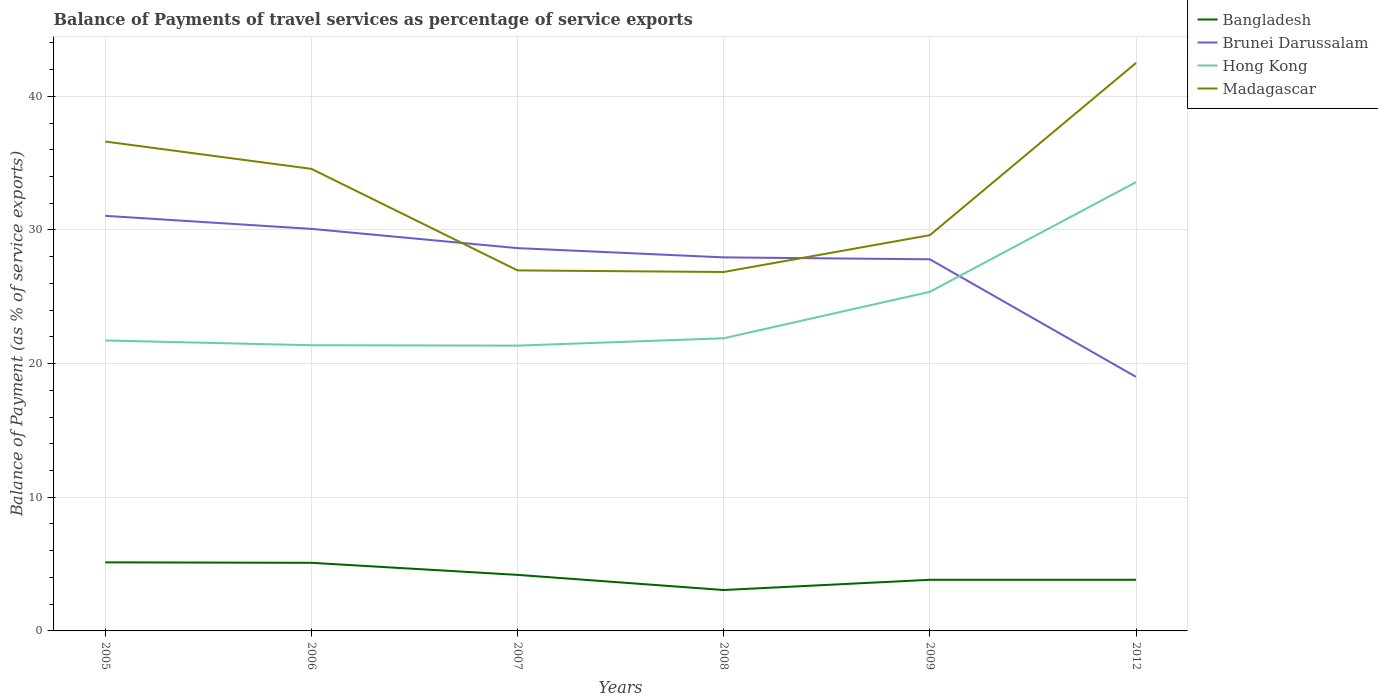Is the number of lines equal to the number of legend labels?
Provide a succinct answer. Yes. Across all years, what is the maximum balance of payments of travel services in Bangladesh?
Offer a very short reply. 3.06. What is the total balance of payments of travel services in Madagascar in the graph?
Your answer should be very brief. 7.01. What is the difference between the highest and the second highest balance of payments of travel services in Bangladesh?
Ensure brevity in your answer.  2.07. How many lines are there?
Your answer should be compact. 4. How many years are there in the graph?
Offer a terse response. 6. Are the values on the major ticks of Y-axis written in scientific E-notation?
Ensure brevity in your answer.  No. Does the graph contain any zero values?
Your answer should be very brief. No. Does the graph contain grids?
Make the answer very short. Yes. Where does the legend appear in the graph?
Make the answer very short. Top right. How are the legend labels stacked?
Your response must be concise. Vertical. What is the title of the graph?
Provide a succinct answer. Balance of Payments of travel services as percentage of service exports. Does "Moldova" appear as one of the legend labels in the graph?
Your answer should be compact. No. What is the label or title of the Y-axis?
Keep it short and to the point. Balance of Payment (as % of service exports). What is the Balance of Payment (as % of service exports) of Bangladesh in 2005?
Your answer should be compact. 5.13. What is the Balance of Payment (as % of service exports) in Brunei Darussalam in 2005?
Offer a terse response. 31.06. What is the Balance of Payment (as % of service exports) in Hong Kong in 2005?
Provide a short and direct response. 21.73. What is the Balance of Payment (as % of service exports) of Madagascar in 2005?
Provide a short and direct response. 36.61. What is the Balance of Payment (as % of service exports) of Bangladesh in 2006?
Your response must be concise. 5.1. What is the Balance of Payment (as % of service exports) in Brunei Darussalam in 2006?
Your response must be concise. 30.08. What is the Balance of Payment (as % of service exports) of Hong Kong in 2006?
Make the answer very short. 21.37. What is the Balance of Payment (as % of service exports) in Madagascar in 2006?
Provide a succinct answer. 34.57. What is the Balance of Payment (as % of service exports) of Bangladesh in 2007?
Give a very brief answer. 4.19. What is the Balance of Payment (as % of service exports) in Brunei Darussalam in 2007?
Give a very brief answer. 28.64. What is the Balance of Payment (as % of service exports) in Hong Kong in 2007?
Your response must be concise. 21.34. What is the Balance of Payment (as % of service exports) of Madagascar in 2007?
Provide a short and direct response. 26.97. What is the Balance of Payment (as % of service exports) of Bangladesh in 2008?
Your answer should be compact. 3.06. What is the Balance of Payment (as % of service exports) of Brunei Darussalam in 2008?
Give a very brief answer. 27.95. What is the Balance of Payment (as % of service exports) in Hong Kong in 2008?
Your answer should be compact. 21.9. What is the Balance of Payment (as % of service exports) in Madagascar in 2008?
Offer a terse response. 26.86. What is the Balance of Payment (as % of service exports) of Bangladesh in 2009?
Your response must be concise. 3.83. What is the Balance of Payment (as % of service exports) of Brunei Darussalam in 2009?
Offer a very short reply. 27.8. What is the Balance of Payment (as % of service exports) of Hong Kong in 2009?
Offer a terse response. 25.37. What is the Balance of Payment (as % of service exports) of Madagascar in 2009?
Provide a succinct answer. 29.61. What is the Balance of Payment (as % of service exports) in Bangladesh in 2012?
Your answer should be very brief. 3.83. What is the Balance of Payment (as % of service exports) of Brunei Darussalam in 2012?
Make the answer very short. 19.01. What is the Balance of Payment (as % of service exports) of Hong Kong in 2012?
Your answer should be compact. 33.58. What is the Balance of Payment (as % of service exports) in Madagascar in 2012?
Give a very brief answer. 42.5. Across all years, what is the maximum Balance of Payment (as % of service exports) in Bangladesh?
Offer a very short reply. 5.13. Across all years, what is the maximum Balance of Payment (as % of service exports) in Brunei Darussalam?
Your response must be concise. 31.06. Across all years, what is the maximum Balance of Payment (as % of service exports) of Hong Kong?
Keep it short and to the point. 33.58. Across all years, what is the maximum Balance of Payment (as % of service exports) of Madagascar?
Ensure brevity in your answer.  42.5. Across all years, what is the minimum Balance of Payment (as % of service exports) in Bangladesh?
Your answer should be very brief. 3.06. Across all years, what is the minimum Balance of Payment (as % of service exports) of Brunei Darussalam?
Give a very brief answer. 19.01. Across all years, what is the minimum Balance of Payment (as % of service exports) of Hong Kong?
Your answer should be compact. 21.34. Across all years, what is the minimum Balance of Payment (as % of service exports) of Madagascar?
Keep it short and to the point. 26.86. What is the total Balance of Payment (as % of service exports) of Bangladesh in the graph?
Provide a short and direct response. 25.13. What is the total Balance of Payment (as % of service exports) of Brunei Darussalam in the graph?
Your answer should be compact. 164.53. What is the total Balance of Payment (as % of service exports) in Hong Kong in the graph?
Give a very brief answer. 145.3. What is the total Balance of Payment (as % of service exports) of Madagascar in the graph?
Your response must be concise. 197.12. What is the difference between the Balance of Payment (as % of service exports) in Bangladesh in 2005 and that in 2006?
Ensure brevity in your answer.  0.04. What is the difference between the Balance of Payment (as % of service exports) in Brunei Darussalam in 2005 and that in 2006?
Your answer should be compact. 0.98. What is the difference between the Balance of Payment (as % of service exports) in Hong Kong in 2005 and that in 2006?
Keep it short and to the point. 0.36. What is the difference between the Balance of Payment (as % of service exports) in Madagascar in 2005 and that in 2006?
Ensure brevity in your answer.  2.04. What is the difference between the Balance of Payment (as % of service exports) in Bangladesh in 2005 and that in 2007?
Make the answer very short. 0.94. What is the difference between the Balance of Payment (as % of service exports) in Brunei Darussalam in 2005 and that in 2007?
Give a very brief answer. 2.42. What is the difference between the Balance of Payment (as % of service exports) of Hong Kong in 2005 and that in 2007?
Your answer should be very brief. 0.39. What is the difference between the Balance of Payment (as % of service exports) in Madagascar in 2005 and that in 2007?
Provide a short and direct response. 9.64. What is the difference between the Balance of Payment (as % of service exports) in Bangladesh in 2005 and that in 2008?
Provide a short and direct response. 2.07. What is the difference between the Balance of Payment (as % of service exports) in Brunei Darussalam in 2005 and that in 2008?
Offer a terse response. 3.11. What is the difference between the Balance of Payment (as % of service exports) of Hong Kong in 2005 and that in 2008?
Provide a short and direct response. -0.17. What is the difference between the Balance of Payment (as % of service exports) of Madagascar in 2005 and that in 2008?
Offer a terse response. 9.76. What is the difference between the Balance of Payment (as % of service exports) of Bangladesh in 2005 and that in 2009?
Keep it short and to the point. 1.31. What is the difference between the Balance of Payment (as % of service exports) of Brunei Darussalam in 2005 and that in 2009?
Make the answer very short. 3.25. What is the difference between the Balance of Payment (as % of service exports) of Hong Kong in 2005 and that in 2009?
Your answer should be compact. -3.64. What is the difference between the Balance of Payment (as % of service exports) of Madagascar in 2005 and that in 2009?
Provide a succinct answer. 7.01. What is the difference between the Balance of Payment (as % of service exports) in Bangladesh in 2005 and that in 2012?
Provide a succinct answer. 1.3. What is the difference between the Balance of Payment (as % of service exports) of Brunei Darussalam in 2005 and that in 2012?
Your response must be concise. 12.05. What is the difference between the Balance of Payment (as % of service exports) of Hong Kong in 2005 and that in 2012?
Offer a very short reply. -11.85. What is the difference between the Balance of Payment (as % of service exports) of Madagascar in 2005 and that in 2012?
Offer a very short reply. -5.88. What is the difference between the Balance of Payment (as % of service exports) in Bangladesh in 2006 and that in 2007?
Your answer should be compact. 0.9. What is the difference between the Balance of Payment (as % of service exports) in Brunei Darussalam in 2006 and that in 2007?
Give a very brief answer. 1.44. What is the difference between the Balance of Payment (as % of service exports) in Hong Kong in 2006 and that in 2007?
Give a very brief answer. 0.03. What is the difference between the Balance of Payment (as % of service exports) of Madagascar in 2006 and that in 2007?
Offer a very short reply. 7.6. What is the difference between the Balance of Payment (as % of service exports) in Bangladesh in 2006 and that in 2008?
Your response must be concise. 2.04. What is the difference between the Balance of Payment (as % of service exports) in Brunei Darussalam in 2006 and that in 2008?
Give a very brief answer. 2.13. What is the difference between the Balance of Payment (as % of service exports) of Hong Kong in 2006 and that in 2008?
Ensure brevity in your answer.  -0.52. What is the difference between the Balance of Payment (as % of service exports) in Madagascar in 2006 and that in 2008?
Provide a short and direct response. 7.72. What is the difference between the Balance of Payment (as % of service exports) in Bangladesh in 2006 and that in 2009?
Offer a terse response. 1.27. What is the difference between the Balance of Payment (as % of service exports) of Brunei Darussalam in 2006 and that in 2009?
Ensure brevity in your answer.  2.28. What is the difference between the Balance of Payment (as % of service exports) of Hong Kong in 2006 and that in 2009?
Ensure brevity in your answer.  -4. What is the difference between the Balance of Payment (as % of service exports) in Madagascar in 2006 and that in 2009?
Provide a short and direct response. 4.96. What is the difference between the Balance of Payment (as % of service exports) in Bangladesh in 2006 and that in 2012?
Offer a terse response. 1.27. What is the difference between the Balance of Payment (as % of service exports) in Brunei Darussalam in 2006 and that in 2012?
Your answer should be compact. 11.07. What is the difference between the Balance of Payment (as % of service exports) of Hong Kong in 2006 and that in 2012?
Offer a terse response. -12.2. What is the difference between the Balance of Payment (as % of service exports) of Madagascar in 2006 and that in 2012?
Your answer should be very brief. -7.92. What is the difference between the Balance of Payment (as % of service exports) of Bangladesh in 2007 and that in 2008?
Keep it short and to the point. 1.13. What is the difference between the Balance of Payment (as % of service exports) of Brunei Darussalam in 2007 and that in 2008?
Your response must be concise. 0.69. What is the difference between the Balance of Payment (as % of service exports) of Hong Kong in 2007 and that in 2008?
Ensure brevity in your answer.  -0.55. What is the difference between the Balance of Payment (as % of service exports) in Madagascar in 2007 and that in 2008?
Keep it short and to the point. 0.12. What is the difference between the Balance of Payment (as % of service exports) in Bangladesh in 2007 and that in 2009?
Your answer should be very brief. 0.37. What is the difference between the Balance of Payment (as % of service exports) in Brunei Darussalam in 2007 and that in 2009?
Your answer should be compact. 0.84. What is the difference between the Balance of Payment (as % of service exports) in Hong Kong in 2007 and that in 2009?
Your response must be concise. -4.03. What is the difference between the Balance of Payment (as % of service exports) in Madagascar in 2007 and that in 2009?
Provide a short and direct response. -2.64. What is the difference between the Balance of Payment (as % of service exports) in Bangladesh in 2007 and that in 2012?
Your response must be concise. 0.37. What is the difference between the Balance of Payment (as % of service exports) of Brunei Darussalam in 2007 and that in 2012?
Provide a short and direct response. 9.63. What is the difference between the Balance of Payment (as % of service exports) in Hong Kong in 2007 and that in 2012?
Offer a terse response. -12.23. What is the difference between the Balance of Payment (as % of service exports) in Madagascar in 2007 and that in 2012?
Your answer should be compact. -15.52. What is the difference between the Balance of Payment (as % of service exports) of Bangladesh in 2008 and that in 2009?
Provide a succinct answer. -0.77. What is the difference between the Balance of Payment (as % of service exports) of Brunei Darussalam in 2008 and that in 2009?
Provide a short and direct response. 0.14. What is the difference between the Balance of Payment (as % of service exports) of Hong Kong in 2008 and that in 2009?
Offer a very short reply. -3.48. What is the difference between the Balance of Payment (as % of service exports) in Madagascar in 2008 and that in 2009?
Keep it short and to the point. -2.75. What is the difference between the Balance of Payment (as % of service exports) in Bangladesh in 2008 and that in 2012?
Your response must be concise. -0.77. What is the difference between the Balance of Payment (as % of service exports) in Brunei Darussalam in 2008 and that in 2012?
Offer a very short reply. 8.94. What is the difference between the Balance of Payment (as % of service exports) in Hong Kong in 2008 and that in 2012?
Your answer should be compact. -11.68. What is the difference between the Balance of Payment (as % of service exports) in Madagascar in 2008 and that in 2012?
Your response must be concise. -15.64. What is the difference between the Balance of Payment (as % of service exports) in Bangladesh in 2009 and that in 2012?
Offer a terse response. -0. What is the difference between the Balance of Payment (as % of service exports) in Brunei Darussalam in 2009 and that in 2012?
Your answer should be compact. 8.8. What is the difference between the Balance of Payment (as % of service exports) in Hong Kong in 2009 and that in 2012?
Keep it short and to the point. -8.21. What is the difference between the Balance of Payment (as % of service exports) of Madagascar in 2009 and that in 2012?
Ensure brevity in your answer.  -12.89. What is the difference between the Balance of Payment (as % of service exports) of Bangladesh in 2005 and the Balance of Payment (as % of service exports) of Brunei Darussalam in 2006?
Provide a short and direct response. -24.95. What is the difference between the Balance of Payment (as % of service exports) in Bangladesh in 2005 and the Balance of Payment (as % of service exports) in Hong Kong in 2006?
Give a very brief answer. -16.24. What is the difference between the Balance of Payment (as % of service exports) of Bangladesh in 2005 and the Balance of Payment (as % of service exports) of Madagascar in 2006?
Keep it short and to the point. -29.44. What is the difference between the Balance of Payment (as % of service exports) in Brunei Darussalam in 2005 and the Balance of Payment (as % of service exports) in Hong Kong in 2006?
Offer a very short reply. 9.68. What is the difference between the Balance of Payment (as % of service exports) in Brunei Darussalam in 2005 and the Balance of Payment (as % of service exports) in Madagascar in 2006?
Provide a succinct answer. -3.51. What is the difference between the Balance of Payment (as % of service exports) in Hong Kong in 2005 and the Balance of Payment (as % of service exports) in Madagascar in 2006?
Your response must be concise. -12.84. What is the difference between the Balance of Payment (as % of service exports) in Bangladesh in 2005 and the Balance of Payment (as % of service exports) in Brunei Darussalam in 2007?
Offer a terse response. -23.51. What is the difference between the Balance of Payment (as % of service exports) of Bangladesh in 2005 and the Balance of Payment (as % of service exports) of Hong Kong in 2007?
Ensure brevity in your answer.  -16.21. What is the difference between the Balance of Payment (as % of service exports) in Bangladesh in 2005 and the Balance of Payment (as % of service exports) in Madagascar in 2007?
Offer a terse response. -21.84. What is the difference between the Balance of Payment (as % of service exports) in Brunei Darussalam in 2005 and the Balance of Payment (as % of service exports) in Hong Kong in 2007?
Your answer should be very brief. 9.71. What is the difference between the Balance of Payment (as % of service exports) in Brunei Darussalam in 2005 and the Balance of Payment (as % of service exports) in Madagascar in 2007?
Your answer should be very brief. 4.08. What is the difference between the Balance of Payment (as % of service exports) of Hong Kong in 2005 and the Balance of Payment (as % of service exports) of Madagascar in 2007?
Offer a terse response. -5.24. What is the difference between the Balance of Payment (as % of service exports) of Bangladesh in 2005 and the Balance of Payment (as % of service exports) of Brunei Darussalam in 2008?
Your answer should be very brief. -22.82. What is the difference between the Balance of Payment (as % of service exports) of Bangladesh in 2005 and the Balance of Payment (as % of service exports) of Hong Kong in 2008?
Your answer should be compact. -16.77. What is the difference between the Balance of Payment (as % of service exports) of Bangladesh in 2005 and the Balance of Payment (as % of service exports) of Madagascar in 2008?
Provide a succinct answer. -21.72. What is the difference between the Balance of Payment (as % of service exports) of Brunei Darussalam in 2005 and the Balance of Payment (as % of service exports) of Hong Kong in 2008?
Provide a succinct answer. 9.16. What is the difference between the Balance of Payment (as % of service exports) in Brunei Darussalam in 2005 and the Balance of Payment (as % of service exports) in Madagascar in 2008?
Provide a short and direct response. 4.2. What is the difference between the Balance of Payment (as % of service exports) of Hong Kong in 2005 and the Balance of Payment (as % of service exports) of Madagascar in 2008?
Provide a succinct answer. -5.13. What is the difference between the Balance of Payment (as % of service exports) in Bangladesh in 2005 and the Balance of Payment (as % of service exports) in Brunei Darussalam in 2009?
Keep it short and to the point. -22.67. What is the difference between the Balance of Payment (as % of service exports) of Bangladesh in 2005 and the Balance of Payment (as % of service exports) of Hong Kong in 2009?
Provide a succinct answer. -20.24. What is the difference between the Balance of Payment (as % of service exports) in Bangladesh in 2005 and the Balance of Payment (as % of service exports) in Madagascar in 2009?
Provide a succinct answer. -24.48. What is the difference between the Balance of Payment (as % of service exports) in Brunei Darussalam in 2005 and the Balance of Payment (as % of service exports) in Hong Kong in 2009?
Make the answer very short. 5.68. What is the difference between the Balance of Payment (as % of service exports) in Brunei Darussalam in 2005 and the Balance of Payment (as % of service exports) in Madagascar in 2009?
Your response must be concise. 1.45. What is the difference between the Balance of Payment (as % of service exports) of Hong Kong in 2005 and the Balance of Payment (as % of service exports) of Madagascar in 2009?
Provide a short and direct response. -7.88. What is the difference between the Balance of Payment (as % of service exports) of Bangladesh in 2005 and the Balance of Payment (as % of service exports) of Brunei Darussalam in 2012?
Ensure brevity in your answer.  -13.88. What is the difference between the Balance of Payment (as % of service exports) of Bangladesh in 2005 and the Balance of Payment (as % of service exports) of Hong Kong in 2012?
Keep it short and to the point. -28.45. What is the difference between the Balance of Payment (as % of service exports) of Bangladesh in 2005 and the Balance of Payment (as % of service exports) of Madagascar in 2012?
Provide a short and direct response. -37.36. What is the difference between the Balance of Payment (as % of service exports) in Brunei Darussalam in 2005 and the Balance of Payment (as % of service exports) in Hong Kong in 2012?
Give a very brief answer. -2.52. What is the difference between the Balance of Payment (as % of service exports) of Brunei Darussalam in 2005 and the Balance of Payment (as % of service exports) of Madagascar in 2012?
Provide a short and direct response. -11.44. What is the difference between the Balance of Payment (as % of service exports) of Hong Kong in 2005 and the Balance of Payment (as % of service exports) of Madagascar in 2012?
Ensure brevity in your answer.  -20.77. What is the difference between the Balance of Payment (as % of service exports) of Bangladesh in 2006 and the Balance of Payment (as % of service exports) of Brunei Darussalam in 2007?
Offer a very short reply. -23.54. What is the difference between the Balance of Payment (as % of service exports) of Bangladesh in 2006 and the Balance of Payment (as % of service exports) of Hong Kong in 2007?
Provide a short and direct response. -16.25. What is the difference between the Balance of Payment (as % of service exports) of Bangladesh in 2006 and the Balance of Payment (as % of service exports) of Madagascar in 2007?
Your response must be concise. -21.88. What is the difference between the Balance of Payment (as % of service exports) in Brunei Darussalam in 2006 and the Balance of Payment (as % of service exports) in Hong Kong in 2007?
Ensure brevity in your answer.  8.74. What is the difference between the Balance of Payment (as % of service exports) in Brunei Darussalam in 2006 and the Balance of Payment (as % of service exports) in Madagascar in 2007?
Provide a short and direct response. 3.11. What is the difference between the Balance of Payment (as % of service exports) in Hong Kong in 2006 and the Balance of Payment (as % of service exports) in Madagascar in 2007?
Provide a short and direct response. -5.6. What is the difference between the Balance of Payment (as % of service exports) of Bangladesh in 2006 and the Balance of Payment (as % of service exports) of Brunei Darussalam in 2008?
Provide a succinct answer. -22.85. What is the difference between the Balance of Payment (as % of service exports) in Bangladesh in 2006 and the Balance of Payment (as % of service exports) in Hong Kong in 2008?
Your answer should be very brief. -16.8. What is the difference between the Balance of Payment (as % of service exports) of Bangladesh in 2006 and the Balance of Payment (as % of service exports) of Madagascar in 2008?
Provide a short and direct response. -21.76. What is the difference between the Balance of Payment (as % of service exports) in Brunei Darussalam in 2006 and the Balance of Payment (as % of service exports) in Hong Kong in 2008?
Provide a succinct answer. 8.18. What is the difference between the Balance of Payment (as % of service exports) in Brunei Darussalam in 2006 and the Balance of Payment (as % of service exports) in Madagascar in 2008?
Provide a succinct answer. 3.23. What is the difference between the Balance of Payment (as % of service exports) of Hong Kong in 2006 and the Balance of Payment (as % of service exports) of Madagascar in 2008?
Your answer should be compact. -5.48. What is the difference between the Balance of Payment (as % of service exports) of Bangladesh in 2006 and the Balance of Payment (as % of service exports) of Brunei Darussalam in 2009?
Provide a short and direct response. -22.71. What is the difference between the Balance of Payment (as % of service exports) in Bangladesh in 2006 and the Balance of Payment (as % of service exports) in Hong Kong in 2009?
Keep it short and to the point. -20.28. What is the difference between the Balance of Payment (as % of service exports) of Bangladesh in 2006 and the Balance of Payment (as % of service exports) of Madagascar in 2009?
Your answer should be very brief. -24.51. What is the difference between the Balance of Payment (as % of service exports) of Brunei Darussalam in 2006 and the Balance of Payment (as % of service exports) of Hong Kong in 2009?
Your response must be concise. 4.71. What is the difference between the Balance of Payment (as % of service exports) in Brunei Darussalam in 2006 and the Balance of Payment (as % of service exports) in Madagascar in 2009?
Ensure brevity in your answer.  0.47. What is the difference between the Balance of Payment (as % of service exports) of Hong Kong in 2006 and the Balance of Payment (as % of service exports) of Madagascar in 2009?
Provide a short and direct response. -8.23. What is the difference between the Balance of Payment (as % of service exports) in Bangladesh in 2006 and the Balance of Payment (as % of service exports) in Brunei Darussalam in 2012?
Offer a terse response. -13.91. What is the difference between the Balance of Payment (as % of service exports) of Bangladesh in 2006 and the Balance of Payment (as % of service exports) of Hong Kong in 2012?
Keep it short and to the point. -28.48. What is the difference between the Balance of Payment (as % of service exports) in Bangladesh in 2006 and the Balance of Payment (as % of service exports) in Madagascar in 2012?
Give a very brief answer. -37.4. What is the difference between the Balance of Payment (as % of service exports) of Brunei Darussalam in 2006 and the Balance of Payment (as % of service exports) of Hong Kong in 2012?
Keep it short and to the point. -3.5. What is the difference between the Balance of Payment (as % of service exports) of Brunei Darussalam in 2006 and the Balance of Payment (as % of service exports) of Madagascar in 2012?
Make the answer very short. -12.42. What is the difference between the Balance of Payment (as % of service exports) of Hong Kong in 2006 and the Balance of Payment (as % of service exports) of Madagascar in 2012?
Offer a terse response. -21.12. What is the difference between the Balance of Payment (as % of service exports) of Bangladesh in 2007 and the Balance of Payment (as % of service exports) of Brunei Darussalam in 2008?
Your answer should be compact. -23.75. What is the difference between the Balance of Payment (as % of service exports) of Bangladesh in 2007 and the Balance of Payment (as % of service exports) of Hong Kong in 2008?
Offer a very short reply. -17.7. What is the difference between the Balance of Payment (as % of service exports) in Bangladesh in 2007 and the Balance of Payment (as % of service exports) in Madagascar in 2008?
Make the answer very short. -22.66. What is the difference between the Balance of Payment (as % of service exports) in Brunei Darussalam in 2007 and the Balance of Payment (as % of service exports) in Hong Kong in 2008?
Your answer should be compact. 6.74. What is the difference between the Balance of Payment (as % of service exports) of Brunei Darussalam in 2007 and the Balance of Payment (as % of service exports) of Madagascar in 2008?
Give a very brief answer. 1.78. What is the difference between the Balance of Payment (as % of service exports) in Hong Kong in 2007 and the Balance of Payment (as % of service exports) in Madagascar in 2008?
Keep it short and to the point. -5.51. What is the difference between the Balance of Payment (as % of service exports) in Bangladesh in 2007 and the Balance of Payment (as % of service exports) in Brunei Darussalam in 2009?
Offer a terse response. -23.61. What is the difference between the Balance of Payment (as % of service exports) in Bangladesh in 2007 and the Balance of Payment (as % of service exports) in Hong Kong in 2009?
Your response must be concise. -21.18. What is the difference between the Balance of Payment (as % of service exports) of Bangladesh in 2007 and the Balance of Payment (as % of service exports) of Madagascar in 2009?
Offer a terse response. -25.42. What is the difference between the Balance of Payment (as % of service exports) in Brunei Darussalam in 2007 and the Balance of Payment (as % of service exports) in Hong Kong in 2009?
Your response must be concise. 3.27. What is the difference between the Balance of Payment (as % of service exports) of Brunei Darussalam in 2007 and the Balance of Payment (as % of service exports) of Madagascar in 2009?
Provide a short and direct response. -0.97. What is the difference between the Balance of Payment (as % of service exports) of Hong Kong in 2007 and the Balance of Payment (as % of service exports) of Madagascar in 2009?
Offer a very short reply. -8.26. What is the difference between the Balance of Payment (as % of service exports) in Bangladesh in 2007 and the Balance of Payment (as % of service exports) in Brunei Darussalam in 2012?
Provide a short and direct response. -14.81. What is the difference between the Balance of Payment (as % of service exports) of Bangladesh in 2007 and the Balance of Payment (as % of service exports) of Hong Kong in 2012?
Provide a succinct answer. -29.38. What is the difference between the Balance of Payment (as % of service exports) in Bangladesh in 2007 and the Balance of Payment (as % of service exports) in Madagascar in 2012?
Provide a short and direct response. -38.3. What is the difference between the Balance of Payment (as % of service exports) of Brunei Darussalam in 2007 and the Balance of Payment (as % of service exports) of Hong Kong in 2012?
Make the answer very short. -4.94. What is the difference between the Balance of Payment (as % of service exports) in Brunei Darussalam in 2007 and the Balance of Payment (as % of service exports) in Madagascar in 2012?
Keep it short and to the point. -13.86. What is the difference between the Balance of Payment (as % of service exports) in Hong Kong in 2007 and the Balance of Payment (as % of service exports) in Madagascar in 2012?
Offer a terse response. -21.15. What is the difference between the Balance of Payment (as % of service exports) in Bangladesh in 2008 and the Balance of Payment (as % of service exports) in Brunei Darussalam in 2009?
Your answer should be compact. -24.74. What is the difference between the Balance of Payment (as % of service exports) in Bangladesh in 2008 and the Balance of Payment (as % of service exports) in Hong Kong in 2009?
Provide a succinct answer. -22.31. What is the difference between the Balance of Payment (as % of service exports) of Bangladesh in 2008 and the Balance of Payment (as % of service exports) of Madagascar in 2009?
Your response must be concise. -26.55. What is the difference between the Balance of Payment (as % of service exports) in Brunei Darussalam in 2008 and the Balance of Payment (as % of service exports) in Hong Kong in 2009?
Provide a short and direct response. 2.58. What is the difference between the Balance of Payment (as % of service exports) in Brunei Darussalam in 2008 and the Balance of Payment (as % of service exports) in Madagascar in 2009?
Your answer should be compact. -1.66. What is the difference between the Balance of Payment (as % of service exports) of Hong Kong in 2008 and the Balance of Payment (as % of service exports) of Madagascar in 2009?
Offer a very short reply. -7.71. What is the difference between the Balance of Payment (as % of service exports) of Bangladesh in 2008 and the Balance of Payment (as % of service exports) of Brunei Darussalam in 2012?
Offer a very short reply. -15.95. What is the difference between the Balance of Payment (as % of service exports) in Bangladesh in 2008 and the Balance of Payment (as % of service exports) in Hong Kong in 2012?
Make the answer very short. -30.52. What is the difference between the Balance of Payment (as % of service exports) of Bangladesh in 2008 and the Balance of Payment (as % of service exports) of Madagascar in 2012?
Give a very brief answer. -39.44. What is the difference between the Balance of Payment (as % of service exports) in Brunei Darussalam in 2008 and the Balance of Payment (as % of service exports) in Hong Kong in 2012?
Give a very brief answer. -5.63. What is the difference between the Balance of Payment (as % of service exports) in Brunei Darussalam in 2008 and the Balance of Payment (as % of service exports) in Madagascar in 2012?
Make the answer very short. -14.55. What is the difference between the Balance of Payment (as % of service exports) of Hong Kong in 2008 and the Balance of Payment (as % of service exports) of Madagascar in 2012?
Your answer should be very brief. -20.6. What is the difference between the Balance of Payment (as % of service exports) in Bangladesh in 2009 and the Balance of Payment (as % of service exports) in Brunei Darussalam in 2012?
Your answer should be very brief. -15.18. What is the difference between the Balance of Payment (as % of service exports) of Bangladesh in 2009 and the Balance of Payment (as % of service exports) of Hong Kong in 2012?
Your answer should be very brief. -29.75. What is the difference between the Balance of Payment (as % of service exports) in Bangladesh in 2009 and the Balance of Payment (as % of service exports) in Madagascar in 2012?
Offer a very short reply. -38.67. What is the difference between the Balance of Payment (as % of service exports) in Brunei Darussalam in 2009 and the Balance of Payment (as % of service exports) in Hong Kong in 2012?
Keep it short and to the point. -5.77. What is the difference between the Balance of Payment (as % of service exports) of Brunei Darussalam in 2009 and the Balance of Payment (as % of service exports) of Madagascar in 2012?
Ensure brevity in your answer.  -14.69. What is the difference between the Balance of Payment (as % of service exports) of Hong Kong in 2009 and the Balance of Payment (as % of service exports) of Madagascar in 2012?
Keep it short and to the point. -17.12. What is the average Balance of Payment (as % of service exports) of Bangladesh per year?
Offer a very short reply. 4.19. What is the average Balance of Payment (as % of service exports) in Brunei Darussalam per year?
Your response must be concise. 27.42. What is the average Balance of Payment (as % of service exports) in Hong Kong per year?
Offer a terse response. 24.22. What is the average Balance of Payment (as % of service exports) of Madagascar per year?
Ensure brevity in your answer.  32.85. In the year 2005, what is the difference between the Balance of Payment (as % of service exports) of Bangladesh and Balance of Payment (as % of service exports) of Brunei Darussalam?
Keep it short and to the point. -25.93. In the year 2005, what is the difference between the Balance of Payment (as % of service exports) of Bangladesh and Balance of Payment (as % of service exports) of Hong Kong?
Ensure brevity in your answer.  -16.6. In the year 2005, what is the difference between the Balance of Payment (as % of service exports) of Bangladesh and Balance of Payment (as % of service exports) of Madagascar?
Give a very brief answer. -31.48. In the year 2005, what is the difference between the Balance of Payment (as % of service exports) in Brunei Darussalam and Balance of Payment (as % of service exports) in Hong Kong?
Provide a succinct answer. 9.33. In the year 2005, what is the difference between the Balance of Payment (as % of service exports) in Brunei Darussalam and Balance of Payment (as % of service exports) in Madagascar?
Your answer should be compact. -5.56. In the year 2005, what is the difference between the Balance of Payment (as % of service exports) in Hong Kong and Balance of Payment (as % of service exports) in Madagascar?
Your response must be concise. -14.88. In the year 2006, what is the difference between the Balance of Payment (as % of service exports) of Bangladesh and Balance of Payment (as % of service exports) of Brunei Darussalam?
Keep it short and to the point. -24.98. In the year 2006, what is the difference between the Balance of Payment (as % of service exports) in Bangladesh and Balance of Payment (as % of service exports) in Hong Kong?
Offer a terse response. -16.28. In the year 2006, what is the difference between the Balance of Payment (as % of service exports) of Bangladesh and Balance of Payment (as % of service exports) of Madagascar?
Ensure brevity in your answer.  -29.48. In the year 2006, what is the difference between the Balance of Payment (as % of service exports) in Brunei Darussalam and Balance of Payment (as % of service exports) in Hong Kong?
Your answer should be compact. 8.71. In the year 2006, what is the difference between the Balance of Payment (as % of service exports) in Brunei Darussalam and Balance of Payment (as % of service exports) in Madagascar?
Your answer should be compact. -4.49. In the year 2006, what is the difference between the Balance of Payment (as % of service exports) in Hong Kong and Balance of Payment (as % of service exports) in Madagascar?
Give a very brief answer. -13.2. In the year 2007, what is the difference between the Balance of Payment (as % of service exports) in Bangladesh and Balance of Payment (as % of service exports) in Brunei Darussalam?
Provide a succinct answer. -24.45. In the year 2007, what is the difference between the Balance of Payment (as % of service exports) of Bangladesh and Balance of Payment (as % of service exports) of Hong Kong?
Provide a short and direct response. -17.15. In the year 2007, what is the difference between the Balance of Payment (as % of service exports) in Bangladesh and Balance of Payment (as % of service exports) in Madagascar?
Ensure brevity in your answer.  -22.78. In the year 2007, what is the difference between the Balance of Payment (as % of service exports) in Brunei Darussalam and Balance of Payment (as % of service exports) in Hong Kong?
Keep it short and to the point. 7.3. In the year 2007, what is the difference between the Balance of Payment (as % of service exports) of Brunei Darussalam and Balance of Payment (as % of service exports) of Madagascar?
Provide a succinct answer. 1.67. In the year 2007, what is the difference between the Balance of Payment (as % of service exports) in Hong Kong and Balance of Payment (as % of service exports) in Madagascar?
Your response must be concise. -5.63. In the year 2008, what is the difference between the Balance of Payment (as % of service exports) in Bangladesh and Balance of Payment (as % of service exports) in Brunei Darussalam?
Your answer should be compact. -24.89. In the year 2008, what is the difference between the Balance of Payment (as % of service exports) in Bangladesh and Balance of Payment (as % of service exports) in Hong Kong?
Make the answer very short. -18.84. In the year 2008, what is the difference between the Balance of Payment (as % of service exports) of Bangladesh and Balance of Payment (as % of service exports) of Madagascar?
Give a very brief answer. -23.79. In the year 2008, what is the difference between the Balance of Payment (as % of service exports) of Brunei Darussalam and Balance of Payment (as % of service exports) of Hong Kong?
Offer a very short reply. 6.05. In the year 2008, what is the difference between the Balance of Payment (as % of service exports) in Brunei Darussalam and Balance of Payment (as % of service exports) in Madagascar?
Your response must be concise. 1.09. In the year 2008, what is the difference between the Balance of Payment (as % of service exports) of Hong Kong and Balance of Payment (as % of service exports) of Madagascar?
Provide a short and direct response. -4.96. In the year 2009, what is the difference between the Balance of Payment (as % of service exports) of Bangladesh and Balance of Payment (as % of service exports) of Brunei Darussalam?
Your answer should be compact. -23.98. In the year 2009, what is the difference between the Balance of Payment (as % of service exports) of Bangladesh and Balance of Payment (as % of service exports) of Hong Kong?
Give a very brief answer. -21.55. In the year 2009, what is the difference between the Balance of Payment (as % of service exports) of Bangladesh and Balance of Payment (as % of service exports) of Madagascar?
Ensure brevity in your answer.  -25.78. In the year 2009, what is the difference between the Balance of Payment (as % of service exports) of Brunei Darussalam and Balance of Payment (as % of service exports) of Hong Kong?
Your answer should be very brief. 2.43. In the year 2009, what is the difference between the Balance of Payment (as % of service exports) of Brunei Darussalam and Balance of Payment (as % of service exports) of Madagascar?
Your answer should be compact. -1.81. In the year 2009, what is the difference between the Balance of Payment (as % of service exports) of Hong Kong and Balance of Payment (as % of service exports) of Madagascar?
Offer a terse response. -4.24. In the year 2012, what is the difference between the Balance of Payment (as % of service exports) in Bangladesh and Balance of Payment (as % of service exports) in Brunei Darussalam?
Provide a short and direct response. -15.18. In the year 2012, what is the difference between the Balance of Payment (as % of service exports) in Bangladesh and Balance of Payment (as % of service exports) in Hong Kong?
Provide a short and direct response. -29.75. In the year 2012, what is the difference between the Balance of Payment (as % of service exports) in Bangladesh and Balance of Payment (as % of service exports) in Madagascar?
Your response must be concise. -38.67. In the year 2012, what is the difference between the Balance of Payment (as % of service exports) in Brunei Darussalam and Balance of Payment (as % of service exports) in Hong Kong?
Give a very brief answer. -14.57. In the year 2012, what is the difference between the Balance of Payment (as % of service exports) in Brunei Darussalam and Balance of Payment (as % of service exports) in Madagascar?
Your answer should be compact. -23.49. In the year 2012, what is the difference between the Balance of Payment (as % of service exports) in Hong Kong and Balance of Payment (as % of service exports) in Madagascar?
Provide a succinct answer. -8.92. What is the ratio of the Balance of Payment (as % of service exports) of Bangladesh in 2005 to that in 2006?
Ensure brevity in your answer.  1.01. What is the ratio of the Balance of Payment (as % of service exports) of Brunei Darussalam in 2005 to that in 2006?
Your answer should be compact. 1.03. What is the ratio of the Balance of Payment (as % of service exports) of Hong Kong in 2005 to that in 2006?
Your response must be concise. 1.02. What is the ratio of the Balance of Payment (as % of service exports) in Madagascar in 2005 to that in 2006?
Make the answer very short. 1.06. What is the ratio of the Balance of Payment (as % of service exports) in Bangladesh in 2005 to that in 2007?
Offer a very short reply. 1.22. What is the ratio of the Balance of Payment (as % of service exports) in Brunei Darussalam in 2005 to that in 2007?
Your response must be concise. 1.08. What is the ratio of the Balance of Payment (as % of service exports) of Hong Kong in 2005 to that in 2007?
Your answer should be compact. 1.02. What is the ratio of the Balance of Payment (as % of service exports) of Madagascar in 2005 to that in 2007?
Keep it short and to the point. 1.36. What is the ratio of the Balance of Payment (as % of service exports) of Bangladesh in 2005 to that in 2008?
Provide a succinct answer. 1.68. What is the ratio of the Balance of Payment (as % of service exports) in Brunei Darussalam in 2005 to that in 2008?
Provide a succinct answer. 1.11. What is the ratio of the Balance of Payment (as % of service exports) of Hong Kong in 2005 to that in 2008?
Give a very brief answer. 0.99. What is the ratio of the Balance of Payment (as % of service exports) of Madagascar in 2005 to that in 2008?
Your answer should be very brief. 1.36. What is the ratio of the Balance of Payment (as % of service exports) in Bangladesh in 2005 to that in 2009?
Keep it short and to the point. 1.34. What is the ratio of the Balance of Payment (as % of service exports) in Brunei Darussalam in 2005 to that in 2009?
Your answer should be very brief. 1.12. What is the ratio of the Balance of Payment (as % of service exports) in Hong Kong in 2005 to that in 2009?
Your answer should be very brief. 0.86. What is the ratio of the Balance of Payment (as % of service exports) in Madagascar in 2005 to that in 2009?
Keep it short and to the point. 1.24. What is the ratio of the Balance of Payment (as % of service exports) of Bangladesh in 2005 to that in 2012?
Offer a very short reply. 1.34. What is the ratio of the Balance of Payment (as % of service exports) in Brunei Darussalam in 2005 to that in 2012?
Provide a short and direct response. 1.63. What is the ratio of the Balance of Payment (as % of service exports) in Hong Kong in 2005 to that in 2012?
Offer a terse response. 0.65. What is the ratio of the Balance of Payment (as % of service exports) of Madagascar in 2005 to that in 2012?
Ensure brevity in your answer.  0.86. What is the ratio of the Balance of Payment (as % of service exports) of Bangladesh in 2006 to that in 2007?
Your answer should be very brief. 1.22. What is the ratio of the Balance of Payment (as % of service exports) in Brunei Darussalam in 2006 to that in 2007?
Make the answer very short. 1.05. What is the ratio of the Balance of Payment (as % of service exports) of Madagascar in 2006 to that in 2007?
Make the answer very short. 1.28. What is the ratio of the Balance of Payment (as % of service exports) of Bangladesh in 2006 to that in 2008?
Your answer should be compact. 1.66. What is the ratio of the Balance of Payment (as % of service exports) of Brunei Darussalam in 2006 to that in 2008?
Provide a short and direct response. 1.08. What is the ratio of the Balance of Payment (as % of service exports) in Hong Kong in 2006 to that in 2008?
Offer a very short reply. 0.98. What is the ratio of the Balance of Payment (as % of service exports) of Madagascar in 2006 to that in 2008?
Provide a short and direct response. 1.29. What is the ratio of the Balance of Payment (as % of service exports) in Bangladesh in 2006 to that in 2009?
Give a very brief answer. 1.33. What is the ratio of the Balance of Payment (as % of service exports) in Brunei Darussalam in 2006 to that in 2009?
Provide a succinct answer. 1.08. What is the ratio of the Balance of Payment (as % of service exports) of Hong Kong in 2006 to that in 2009?
Provide a succinct answer. 0.84. What is the ratio of the Balance of Payment (as % of service exports) of Madagascar in 2006 to that in 2009?
Offer a terse response. 1.17. What is the ratio of the Balance of Payment (as % of service exports) in Bangladesh in 2006 to that in 2012?
Your response must be concise. 1.33. What is the ratio of the Balance of Payment (as % of service exports) in Brunei Darussalam in 2006 to that in 2012?
Keep it short and to the point. 1.58. What is the ratio of the Balance of Payment (as % of service exports) in Hong Kong in 2006 to that in 2012?
Provide a succinct answer. 0.64. What is the ratio of the Balance of Payment (as % of service exports) in Madagascar in 2006 to that in 2012?
Give a very brief answer. 0.81. What is the ratio of the Balance of Payment (as % of service exports) in Bangladesh in 2007 to that in 2008?
Ensure brevity in your answer.  1.37. What is the ratio of the Balance of Payment (as % of service exports) in Brunei Darussalam in 2007 to that in 2008?
Ensure brevity in your answer.  1.02. What is the ratio of the Balance of Payment (as % of service exports) of Hong Kong in 2007 to that in 2008?
Offer a very short reply. 0.97. What is the ratio of the Balance of Payment (as % of service exports) in Madagascar in 2007 to that in 2008?
Offer a very short reply. 1. What is the ratio of the Balance of Payment (as % of service exports) of Bangladesh in 2007 to that in 2009?
Ensure brevity in your answer.  1.1. What is the ratio of the Balance of Payment (as % of service exports) of Brunei Darussalam in 2007 to that in 2009?
Offer a very short reply. 1.03. What is the ratio of the Balance of Payment (as % of service exports) of Hong Kong in 2007 to that in 2009?
Provide a short and direct response. 0.84. What is the ratio of the Balance of Payment (as % of service exports) of Madagascar in 2007 to that in 2009?
Provide a short and direct response. 0.91. What is the ratio of the Balance of Payment (as % of service exports) of Bangladesh in 2007 to that in 2012?
Offer a terse response. 1.1. What is the ratio of the Balance of Payment (as % of service exports) of Brunei Darussalam in 2007 to that in 2012?
Ensure brevity in your answer.  1.51. What is the ratio of the Balance of Payment (as % of service exports) of Hong Kong in 2007 to that in 2012?
Offer a terse response. 0.64. What is the ratio of the Balance of Payment (as % of service exports) in Madagascar in 2007 to that in 2012?
Provide a succinct answer. 0.63. What is the ratio of the Balance of Payment (as % of service exports) of Brunei Darussalam in 2008 to that in 2009?
Offer a terse response. 1.01. What is the ratio of the Balance of Payment (as % of service exports) of Hong Kong in 2008 to that in 2009?
Provide a succinct answer. 0.86. What is the ratio of the Balance of Payment (as % of service exports) in Madagascar in 2008 to that in 2009?
Make the answer very short. 0.91. What is the ratio of the Balance of Payment (as % of service exports) in Bangladesh in 2008 to that in 2012?
Your answer should be compact. 0.8. What is the ratio of the Balance of Payment (as % of service exports) in Brunei Darussalam in 2008 to that in 2012?
Keep it short and to the point. 1.47. What is the ratio of the Balance of Payment (as % of service exports) in Hong Kong in 2008 to that in 2012?
Make the answer very short. 0.65. What is the ratio of the Balance of Payment (as % of service exports) in Madagascar in 2008 to that in 2012?
Provide a succinct answer. 0.63. What is the ratio of the Balance of Payment (as % of service exports) in Bangladesh in 2009 to that in 2012?
Offer a very short reply. 1. What is the ratio of the Balance of Payment (as % of service exports) of Brunei Darussalam in 2009 to that in 2012?
Provide a short and direct response. 1.46. What is the ratio of the Balance of Payment (as % of service exports) in Hong Kong in 2009 to that in 2012?
Make the answer very short. 0.76. What is the ratio of the Balance of Payment (as % of service exports) in Madagascar in 2009 to that in 2012?
Keep it short and to the point. 0.7. What is the difference between the highest and the second highest Balance of Payment (as % of service exports) in Bangladesh?
Offer a very short reply. 0.04. What is the difference between the highest and the second highest Balance of Payment (as % of service exports) in Brunei Darussalam?
Your response must be concise. 0.98. What is the difference between the highest and the second highest Balance of Payment (as % of service exports) of Hong Kong?
Your answer should be very brief. 8.21. What is the difference between the highest and the second highest Balance of Payment (as % of service exports) of Madagascar?
Your answer should be compact. 5.88. What is the difference between the highest and the lowest Balance of Payment (as % of service exports) in Bangladesh?
Provide a succinct answer. 2.07. What is the difference between the highest and the lowest Balance of Payment (as % of service exports) of Brunei Darussalam?
Provide a short and direct response. 12.05. What is the difference between the highest and the lowest Balance of Payment (as % of service exports) in Hong Kong?
Your answer should be very brief. 12.23. What is the difference between the highest and the lowest Balance of Payment (as % of service exports) in Madagascar?
Your response must be concise. 15.64. 